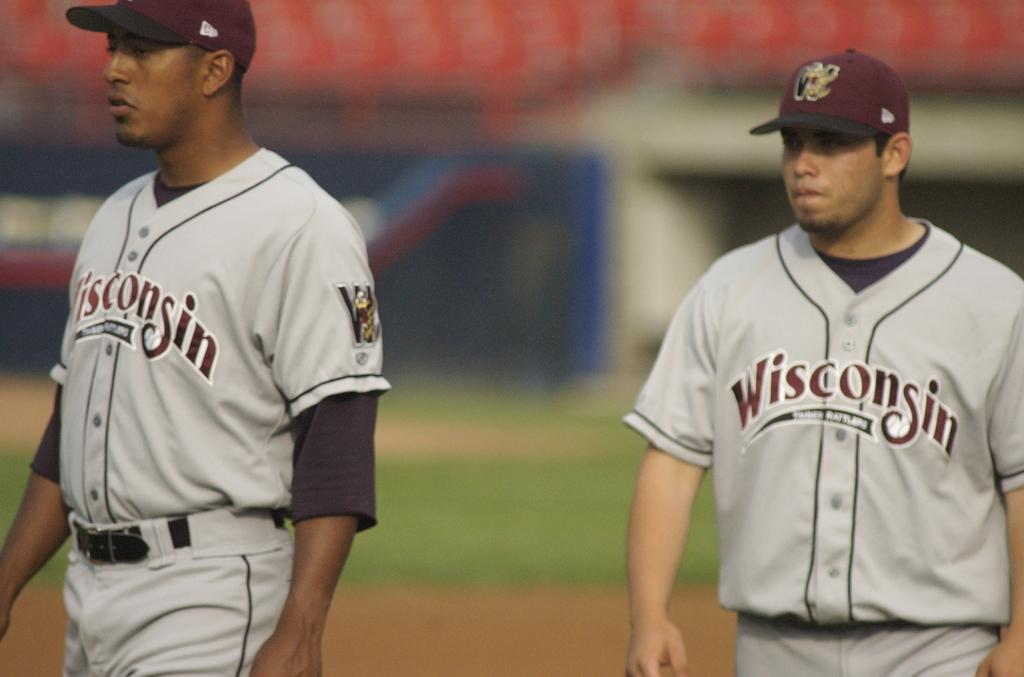<image>
Write a terse but informative summary of the picture. Two baseball players wearing jerseys that says Wisconsin. 